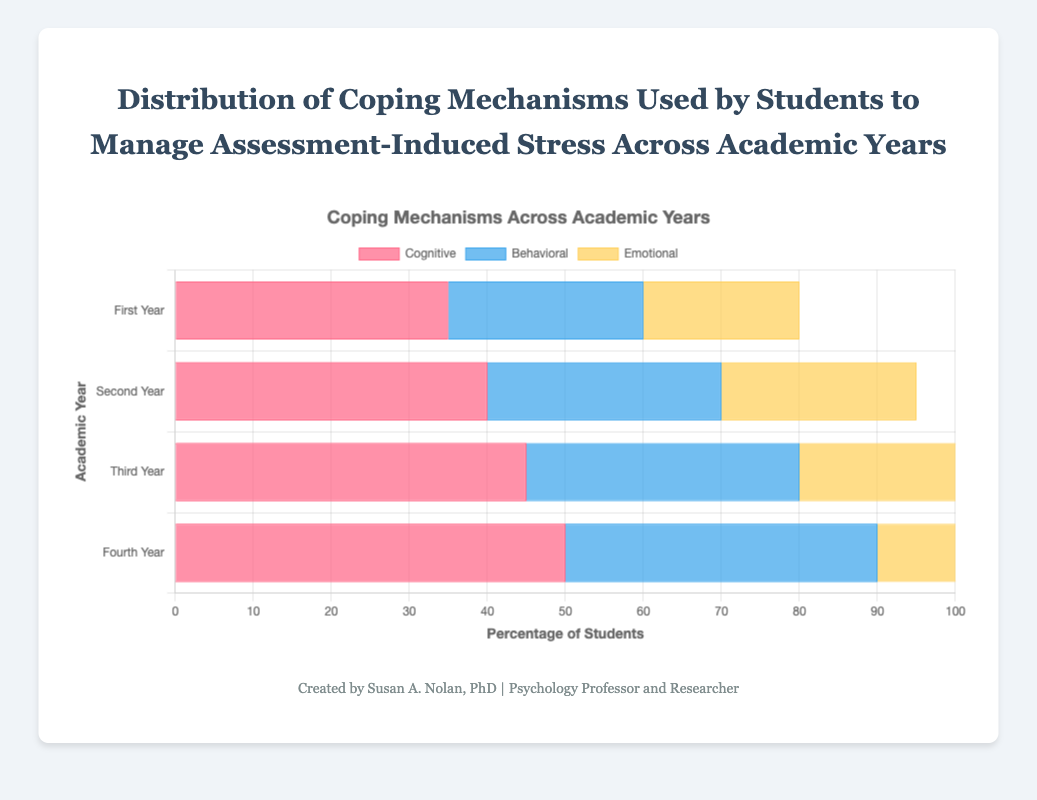What percentage of third-year students use emotional coping mechanisms? Look at the bar for "Emotional" in the "Third Year" category to find the percentage.
Answer: 30% Which coping mechanism has the highest usage among first-year students? Compare the heights of the bars for "Cognitive," "Behavioral," and "Emotional" in the "First Year" category. The highest bar indicates the most used mechanism.
Answer: Cognitive How does the use of behavioral coping mechanisms change from the second to the fourth year? Calculate the difference between the heights of the bars for "Behavioral" in the "Second Year" and "Fourth Year" categories.
Answer: Increased by 10% What is the average percentage of students using cognitive coping mechanisms across all academic years? Add the percentages of students using cognitive coping mechanisms for each academic year (35 + 40 + 45 + 50), then divide by the number of academic years (4).
Answer: 42.5% Is there a year where the use of emotional coping mechanisms is higher than behavioral mechanisms? If so, which year? Compare the heights of the bars for "Emotional" and "Behavioral" across all academic years.
Answer: No Which academic year shows the highest overall usage of coping mechanisms? Sum the heights of the three bars (Cognitive, Behavioral, Emotional) for each academic year and compare.
Answer: Fourth Year What is the total percentage of first-year students using cognitive and behavioral coping mechanisms? Add the percentages of first-year students using cognitive and behavioral mechanisms (35 + 25).
Answer: 60% Does the pattern of increasing usage for cognitive mechanisms continue consistently across all academic years? Analyze if there is a continuous increase in percentages for cognitive mechanisms from "First Year" to "Fourth Year".
Answer: Yes Compare the increase in percentages of behavioral coping mechanisms between the first and second year to the increase between the third and fourth year. Which is larger? Calculate the increase between first and second year (30 - 25 = 5) and between third and fourth year (40 - 35 = 5), then compare.
Answer: Both are equal (5%) 